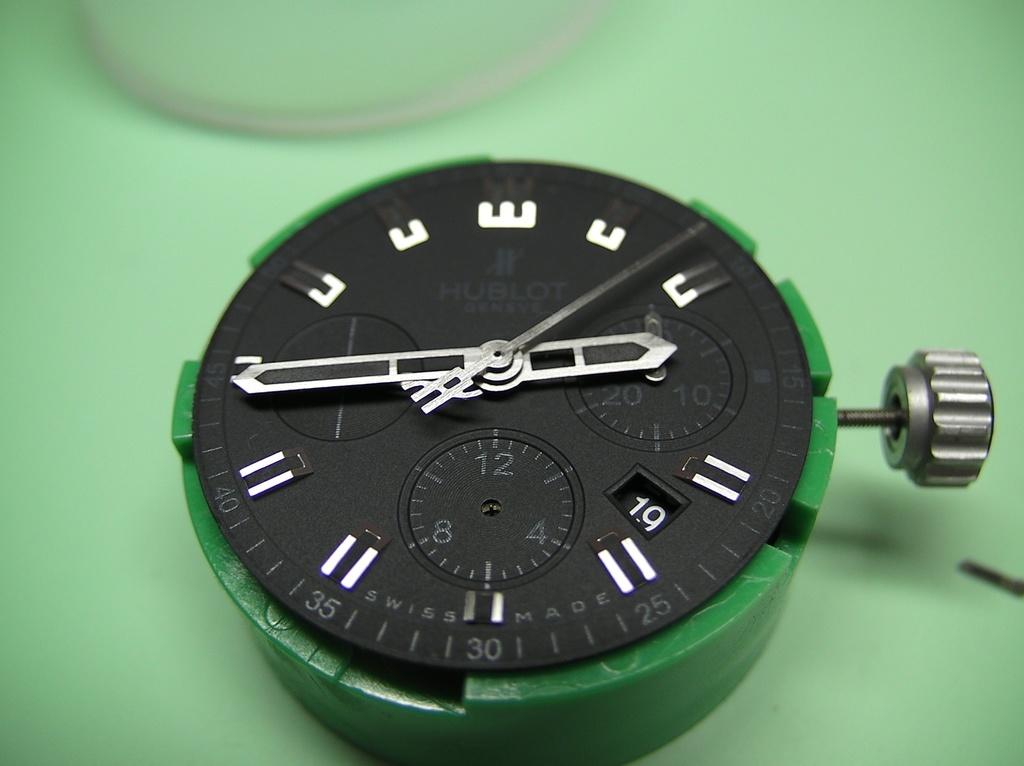What time is it?
Your response must be concise. Unanswerable. What is the short hand on?
Offer a very short reply. 3. 